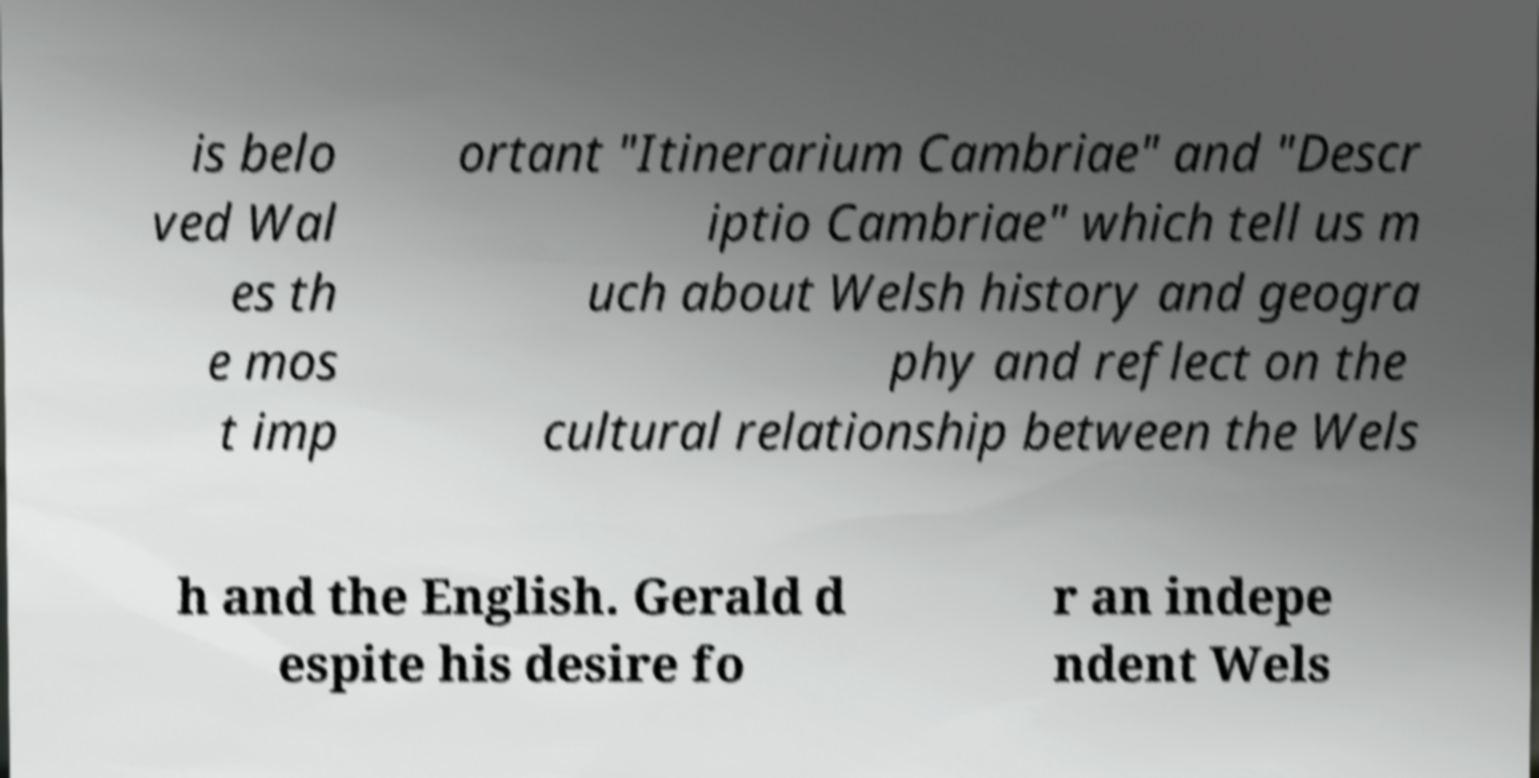Can you accurately transcribe the text from the provided image for me? is belo ved Wal es th e mos t imp ortant "Itinerarium Cambriae" and "Descr iptio Cambriae" which tell us m uch about Welsh history and geogra phy and reflect on the cultural relationship between the Wels h and the English. Gerald d espite his desire fo r an indepe ndent Wels 